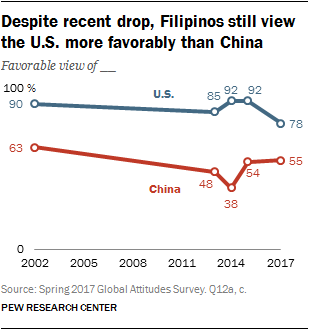Identify some key points in this picture. The blue graph contains points with similarities of 92, specifically points with a value of 2. In 2014, the value of the red bar dipped. 